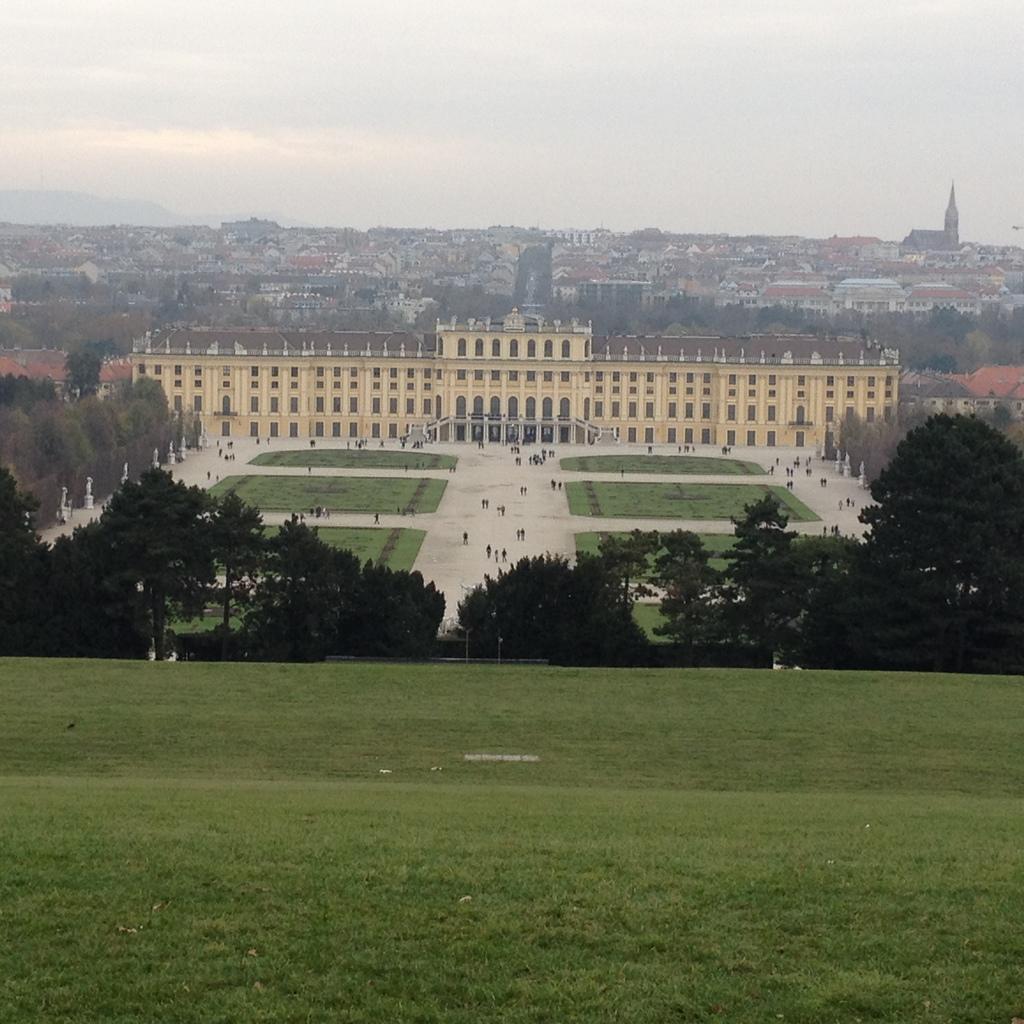Could you give a brief overview of what you see in this image? In this image I can see few buildings, few trees, green grass and few people around. The sky is in white and blue color. 